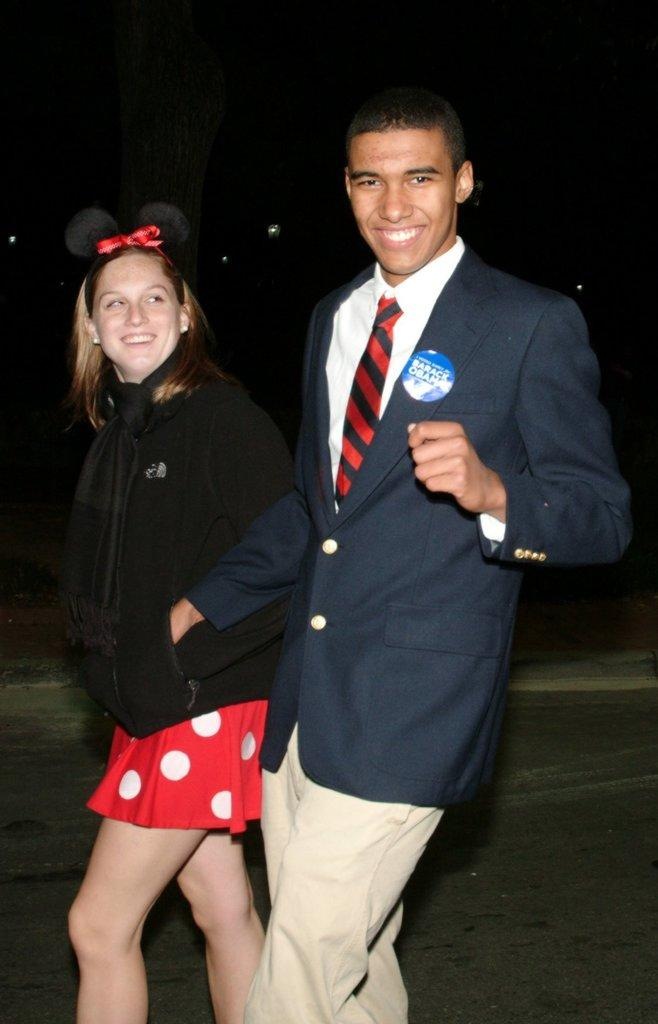Who is present in the image? There is a couple in the image. What are the couple doing in the image? The couple is walking on the road. What is the emotional expression of the couple? The couple is smiling. What can be observed about the lighting in the image? The background of the image is dark. What type of card is being held by the couple in the image? There is no card present in the image; the couple is simply walking and smiling. Where is the quiver located in the image? There is no quiver present in the image. 